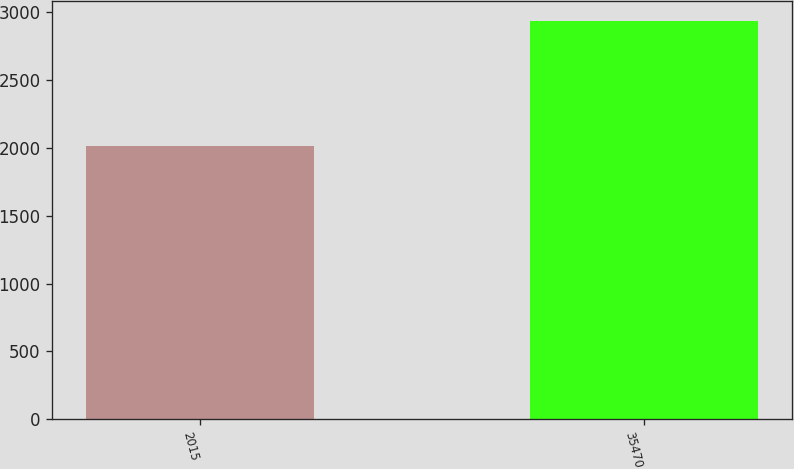Convert chart. <chart><loc_0><loc_0><loc_500><loc_500><bar_chart><fcel>2015<fcel>35470<nl><fcel>2014<fcel>2934.8<nl></chart> 